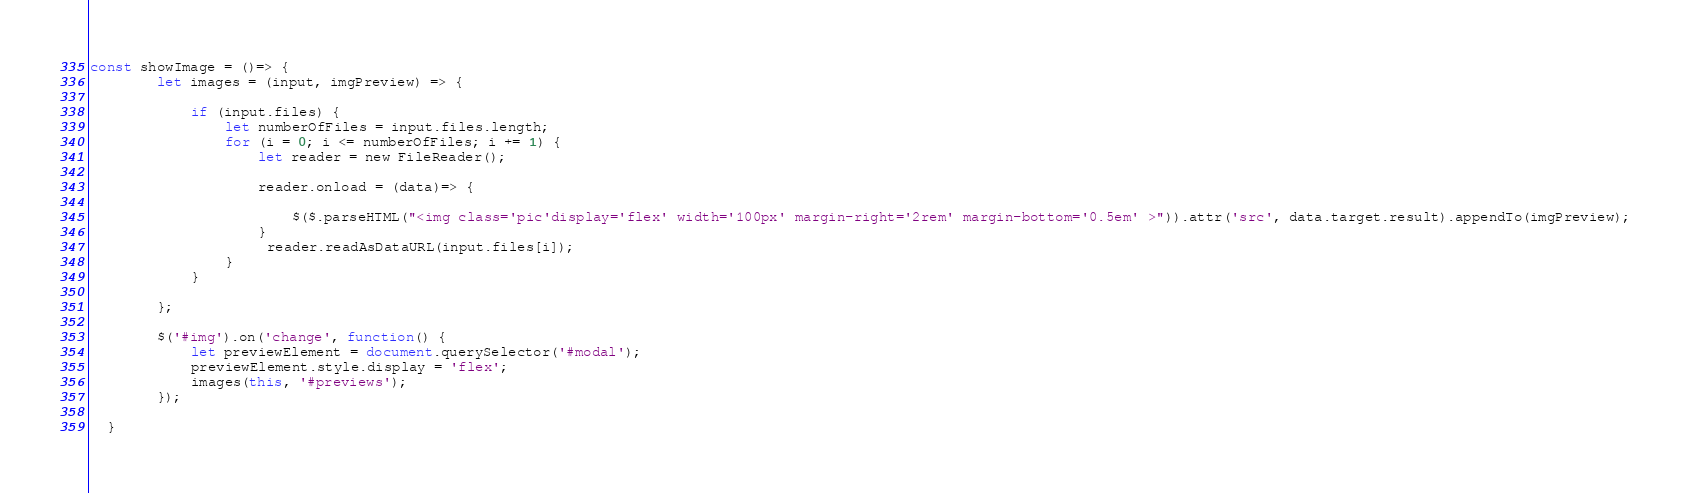<code> <loc_0><loc_0><loc_500><loc_500><_JavaScript_>const showImage = ()=> {
        let images = (input, imgPreview) => {
    
            if (input.files) {
                let numberOfFiles = input.files.length;
                for (i = 0; i <= numberOfFiles; i += 1) {
                    let reader = new FileReader();
    
                    reader.onload = (data)=> {

                        $($.parseHTML("<img class='pic'display='flex' width='100px' margin-right='2rem' margin-bottom='0.5em' >")).attr('src', data.target.result).appendTo(imgPreview);
                    }
                     reader.readAsDataURL(input.files[i]);
                }
            }
    
        };

        $('#img').on('change', function() {
            let previewElement = document.querySelector('#modal');
            previewElement.style.display = 'flex';
            images(this, '#previews');
        });
            
  }
</code> 